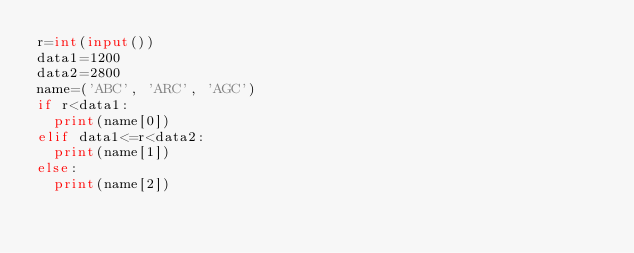Convert code to text. <code><loc_0><loc_0><loc_500><loc_500><_Python_>r=int(input())
data1=1200
data2=2800
name=('ABC', 'ARC', 'AGC')
if r<data1:
  print(name[0])
elif data1<=r<data2:
  print(name[1])
else:
  print(name[2])</code> 